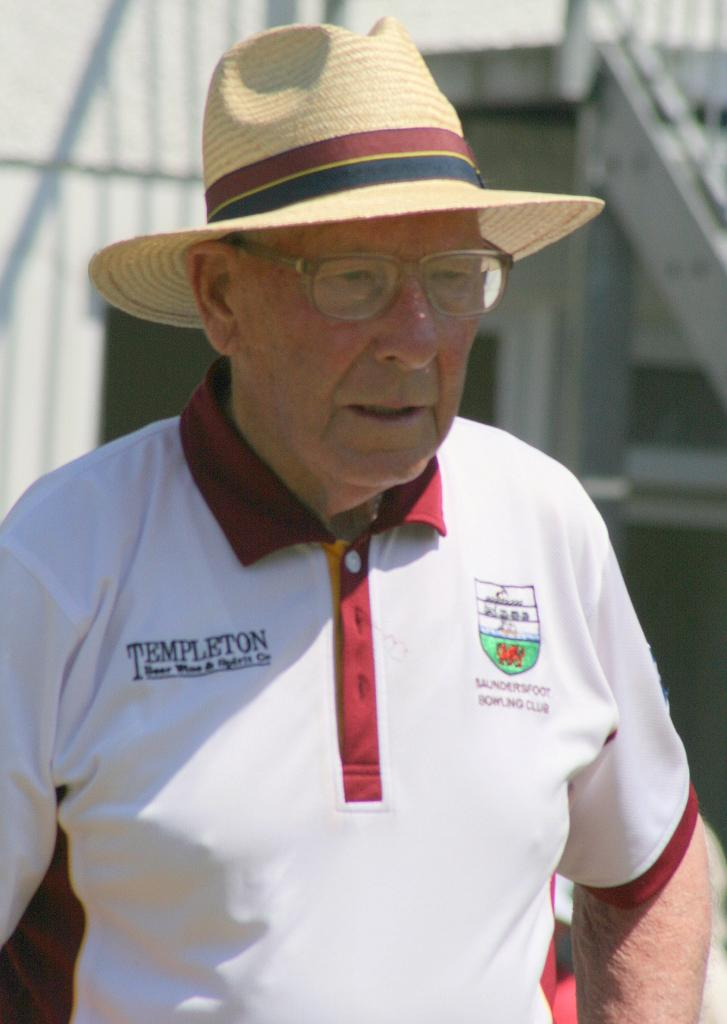<image>
Create a compact narrative representing the image presented. An older man wearing a straw hat and a Saundersfoot Bowling Club polo shirt. 